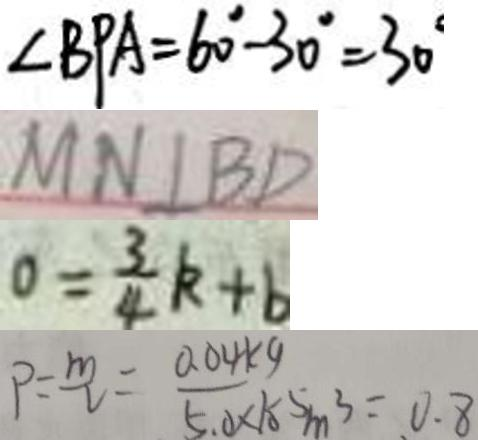Convert formula to latex. <formula><loc_0><loc_0><loc_500><loc_500>\angle B P A = 6 0 ^ { \circ } - 3 0 ^ { \circ } = 3 0 ^ { \circ } 
 M N \bot B D 
 0 = \frac { 3 } { 4 } k + b 
 P = \frac { m } { v } = \frac { 0 . 0 4 k g } { 5 . 0 \times 1 0 ^ { - 5 } m ^ { 3 } } = 0 . 8</formula> 